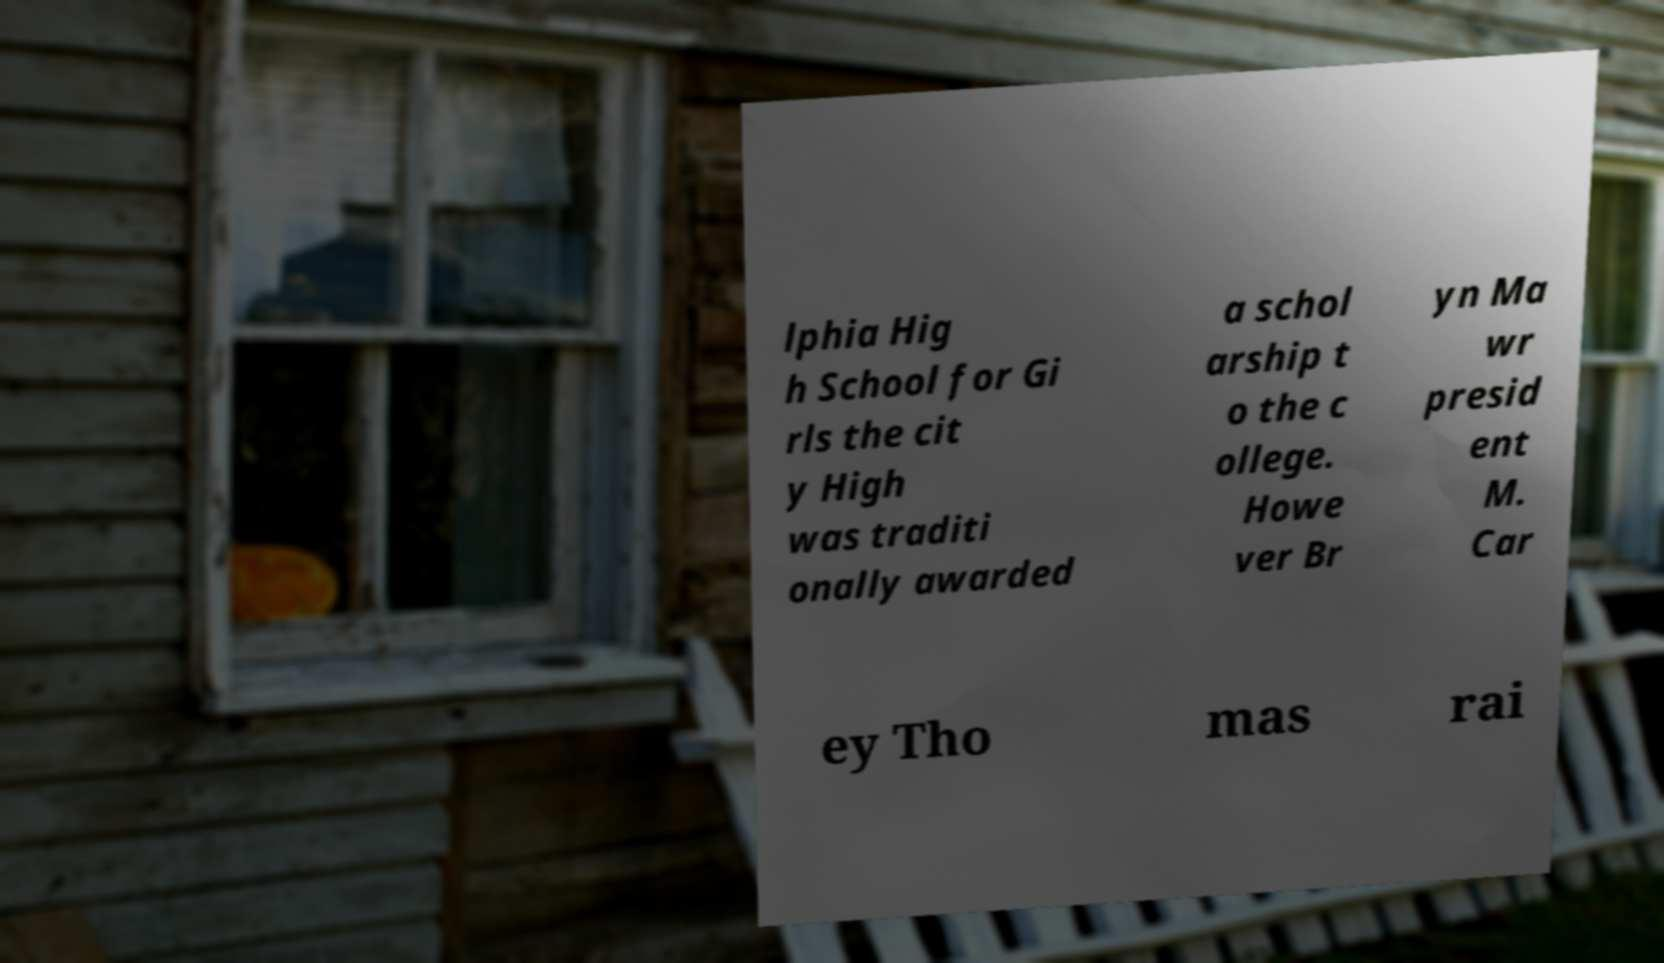What messages or text are displayed in this image? I need them in a readable, typed format. lphia Hig h School for Gi rls the cit y High was traditi onally awarded a schol arship t o the c ollege. Howe ver Br yn Ma wr presid ent M. Car ey Tho mas rai 